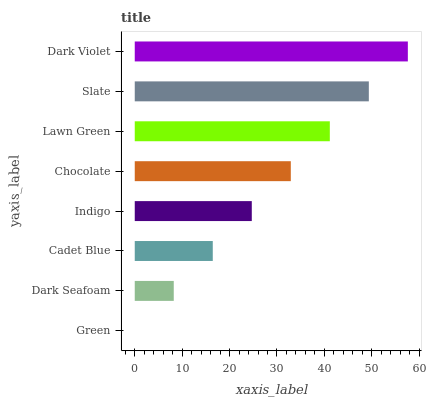Is Green the minimum?
Answer yes or no. Yes. Is Dark Violet the maximum?
Answer yes or no. Yes. Is Dark Seafoam the minimum?
Answer yes or no. No. Is Dark Seafoam the maximum?
Answer yes or no. No. Is Dark Seafoam greater than Green?
Answer yes or no. Yes. Is Green less than Dark Seafoam?
Answer yes or no. Yes. Is Green greater than Dark Seafoam?
Answer yes or no. No. Is Dark Seafoam less than Green?
Answer yes or no. No. Is Chocolate the high median?
Answer yes or no. Yes. Is Indigo the low median?
Answer yes or no. Yes. Is Green the high median?
Answer yes or no. No. Is Chocolate the low median?
Answer yes or no. No. 